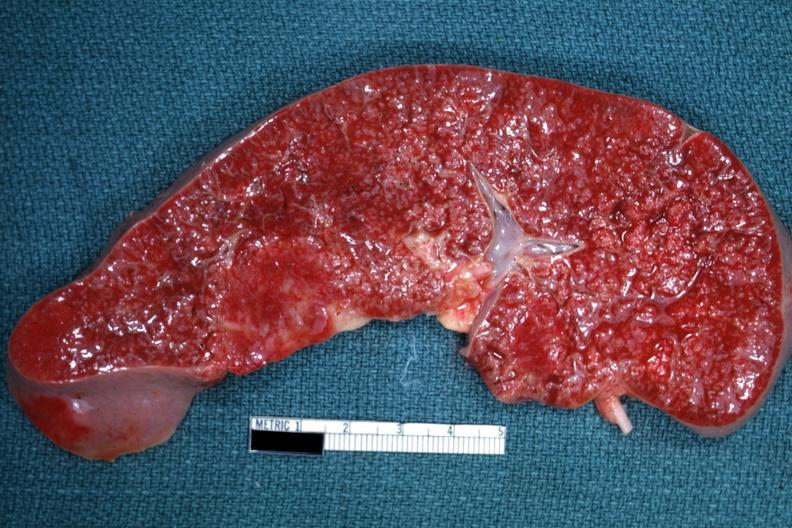what is present?
Answer the question using a single word or phrase. Hematologic 